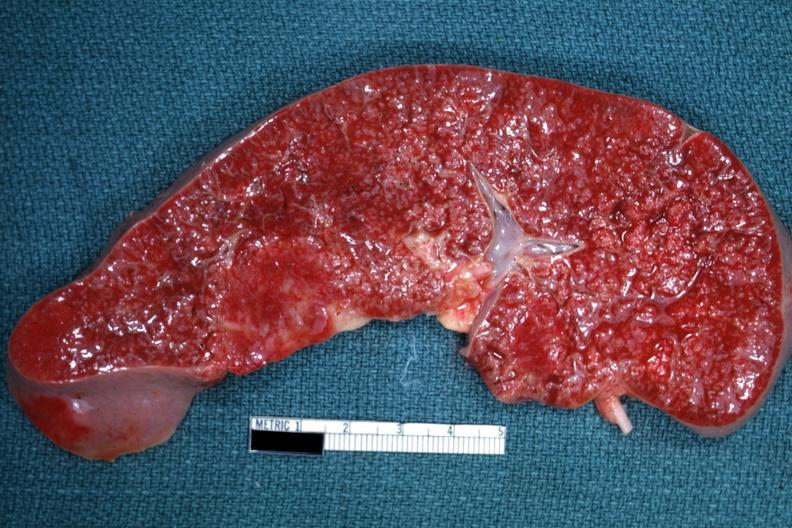what is present?
Answer the question using a single word or phrase. Hematologic 